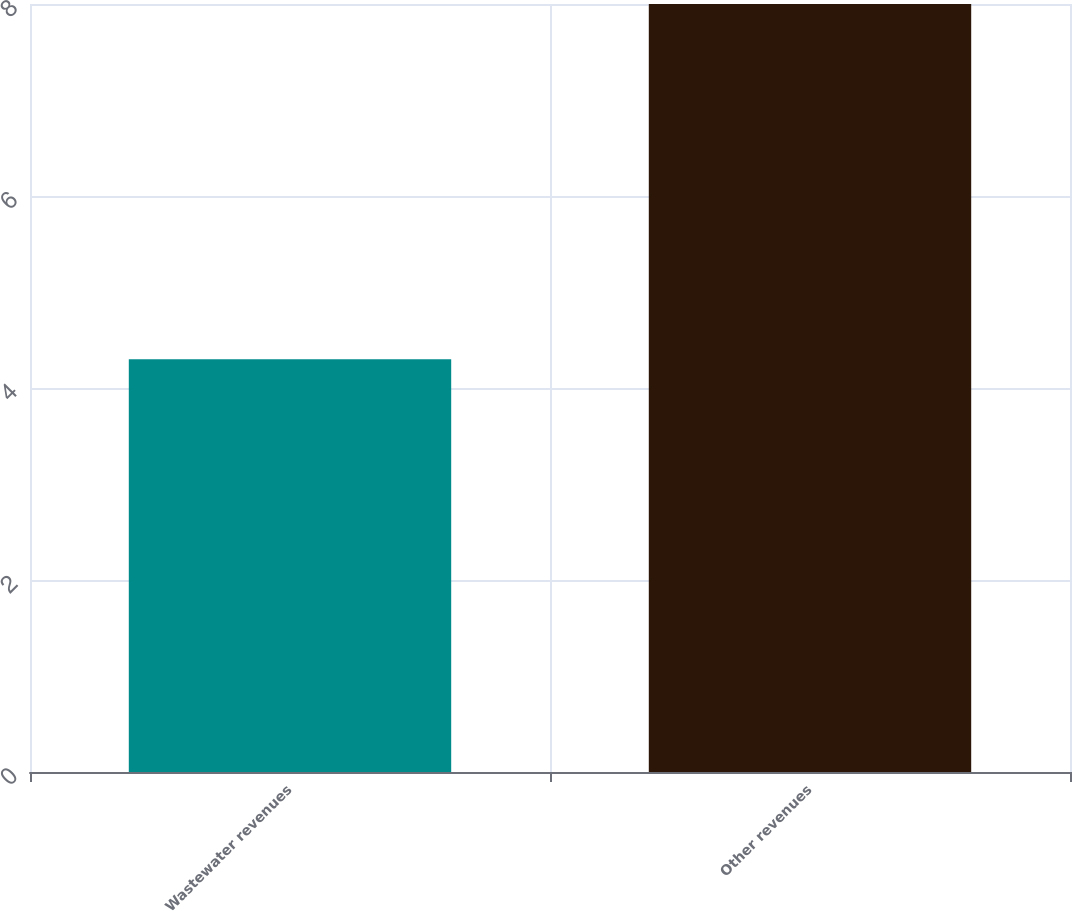Convert chart. <chart><loc_0><loc_0><loc_500><loc_500><bar_chart><fcel>Wastewater revenues<fcel>Other revenues<nl><fcel>4.3<fcel>8<nl></chart> 